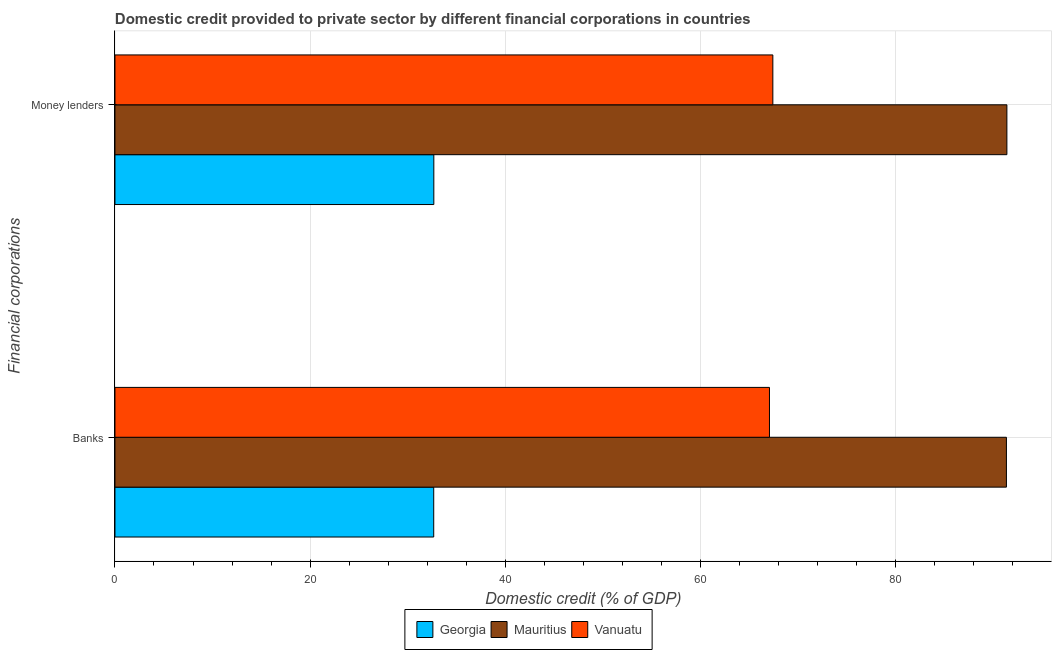How many different coloured bars are there?
Your answer should be compact. 3. How many groups of bars are there?
Your response must be concise. 2. Are the number of bars on each tick of the Y-axis equal?
Keep it short and to the point. Yes. How many bars are there on the 2nd tick from the top?
Your answer should be compact. 3. How many bars are there on the 2nd tick from the bottom?
Keep it short and to the point. 3. What is the label of the 2nd group of bars from the top?
Give a very brief answer. Banks. What is the domestic credit provided by banks in Mauritius?
Ensure brevity in your answer.  91.37. Across all countries, what is the maximum domestic credit provided by money lenders?
Your response must be concise. 91.42. Across all countries, what is the minimum domestic credit provided by money lenders?
Ensure brevity in your answer.  32.68. In which country was the domestic credit provided by money lenders maximum?
Your response must be concise. Mauritius. In which country was the domestic credit provided by banks minimum?
Provide a succinct answer. Georgia. What is the total domestic credit provided by banks in the graph?
Make the answer very short. 191.12. What is the difference between the domestic credit provided by banks in Vanuatu and that in Mauritius?
Your response must be concise. -24.29. What is the difference between the domestic credit provided by banks in Vanuatu and the domestic credit provided by money lenders in Mauritius?
Make the answer very short. -24.33. What is the average domestic credit provided by banks per country?
Provide a short and direct response. 63.71. What is the difference between the domestic credit provided by banks and domestic credit provided by money lenders in Georgia?
Offer a terse response. -0.01. In how many countries, is the domestic credit provided by banks greater than 4 %?
Your answer should be compact. 3. What is the ratio of the domestic credit provided by banks in Georgia to that in Mauritius?
Make the answer very short. 0.36. Is the domestic credit provided by banks in Georgia less than that in Mauritius?
Make the answer very short. Yes. In how many countries, is the domestic credit provided by money lenders greater than the average domestic credit provided by money lenders taken over all countries?
Keep it short and to the point. 2. What does the 3rd bar from the top in Banks represents?
Your answer should be very brief. Georgia. What does the 3rd bar from the bottom in Banks represents?
Your response must be concise. Vanuatu. How many bars are there?
Give a very brief answer. 6. Does the graph contain grids?
Make the answer very short. Yes. Where does the legend appear in the graph?
Give a very brief answer. Bottom center. How many legend labels are there?
Keep it short and to the point. 3. How are the legend labels stacked?
Offer a terse response. Horizontal. What is the title of the graph?
Give a very brief answer. Domestic credit provided to private sector by different financial corporations in countries. What is the label or title of the X-axis?
Keep it short and to the point. Domestic credit (% of GDP). What is the label or title of the Y-axis?
Your response must be concise. Financial corporations. What is the Domestic credit (% of GDP) of Georgia in Banks?
Your answer should be very brief. 32.67. What is the Domestic credit (% of GDP) in Mauritius in Banks?
Your answer should be compact. 91.37. What is the Domestic credit (% of GDP) in Vanuatu in Banks?
Your response must be concise. 67.08. What is the Domestic credit (% of GDP) in Georgia in Money lenders?
Your answer should be very brief. 32.68. What is the Domestic credit (% of GDP) in Mauritius in Money lenders?
Offer a very short reply. 91.42. What is the Domestic credit (% of GDP) in Vanuatu in Money lenders?
Offer a terse response. 67.43. Across all Financial corporations, what is the maximum Domestic credit (% of GDP) of Georgia?
Provide a succinct answer. 32.68. Across all Financial corporations, what is the maximum Domestic credit (% of GDP) of Mauritius?
Offer a terse response. 91.42. Across all Financial corporations, what is the maximum Domestic credit (% of GDP) in Vanuatu?
Provide a succinct answer. 67.43. Across all Financial corporations, what is the minimum Domestic credit (% of GDP) of Georgia?
Keep it short and to the point. 32.67. Across all Financial corporations, what is the minimum Domestic credit (% of GDP) of Mauritius?
Your response must be concise. 91.37. Across all Financial corporations, what is the minimum Domestic credit (% of GDP) of Vanuatu?
Make the answer very short. 67.08. What is the total Domestic credit (% of GDP) of Georgia in the graph?
Provide a succinct answer. 65.35. What is the total Domestic credit (% of GDP) of Mauritius in the graph?
Your response must be concise. 182.78. What is the total Domestic credit (% of GDP) in Vanuatu in the graph?
Offer a very short reply. 134.51. What is the difference between the Domestic credit (% of GDP) in Georgia in Banks and that in Money lenders?
Your answer should be compact. -0.01. What is the difference between the Domestic credit (% of GDP) of Mauritius in Banks and that in Money lenders?
Offer a terse response. -0.05. What is the difference between the Domestic credit (% of GDP) in Vanuatu in Banks and that in Money lenders?
Ensure brevity in your answer.  -0.35. What is the difference between the Domestic credit (% of GDP) of Georgia in Banks and the Domestic credit (% of GDP) of Mauritius in Money lenders?
Your response must be concise. -58.75. What is the difference between the Domestic credit (% of GDP) in Georgia in Banks and the Domestic credit (% of GDP) in Vanuatu in Money lenders?
Your answer should be compact. -34.76. What is the difference between the Domestic credit (% of GDP) of Mauritius in Banks and the Domestic credit (% of GDP) of Vanuatu in Money lenders?
Your response must be concise. 23.94. What is the average Domestic credit (% of GDP) of Georgia per Financial corporations?
Give a very brief answer. 32.68. What is the average Domestic credit (% of GDP) of Mauritius per Financial corporations?
Your answer should be compact. 91.39. What is the average Domestic credit (% of GDP) in Vanuatu per Financial corporations?
Your response must be concise. 67.26. What is the difference between the Domestic credit (% of GDP) in Georgia and Domestic credit (% of GDP) in Mauritius in Banks?
Your answer should be compact. -58.7. What is the difference between the Domestic credit (% of GDP) of Georgia and Domestic credit (% of GDP) of Vanuatu in Banks?
Ensure brevity in your answer.  -34.41. What is the difference between the Domestic credit (% of GDP) in Mauritius and Domestic credit (% of GDP) in Vanuatu in Banks?
Offer a terse response. 24.29. What is the difference between the Domestic credit (% of GDP) in Georgia and Domestic credit (% of GDP) in Mauritius in Money lenders?
Ensure brevity in your answer.  -58.74. What is the difference between the Domestic credit (% of GDP) in Georgia and Domestic credit (% of GDP) in Vanuatu in Money lenders?
Your response must be concise. -34.75. What is the difference between the Domestic credit (% of GDP) in Mauritius and Domestic credit (% of GDP) in Vanuatu in Money lenders?
Keep it short and to the point. 23.99. What is the ratio of the Domestic credit (% of GDP) of Georgia in Banks to that in Money lenders?
Keep it short and to the point. 1. What is the ratio of the Domestic credit (% of GDP) of Mauritius in Banks to that in Money lenders?
Offer a very short reply. 1. What is the difference between the highest and the second highest Domestic credit (% of GDP) of Georgia?
Make the answer very short. 0.01. What is the difference between the highest and the second highest Domestic credit (% of GDP) of Mauritius?
Make the answer very short. 0.05. What is the difference between the highest and the second highest Domestic credit (% of GDP) in Vanuatu?
Ensure brevity in your answer.  0.35. What is the difference between the highest and the lowest Domestic credit (% of GDP) in Georgia?
Your answer should be compact. 0.01. What is the difference between the highest and the lowest Domestic credit (% of GDP) of Mauritius?
Provide a short and direct response. 0.05. What is the difference between the highest and the lowest Domestic credit (% of GDP) of Vanuatu?
Your answer should be very brief. 0.35. 